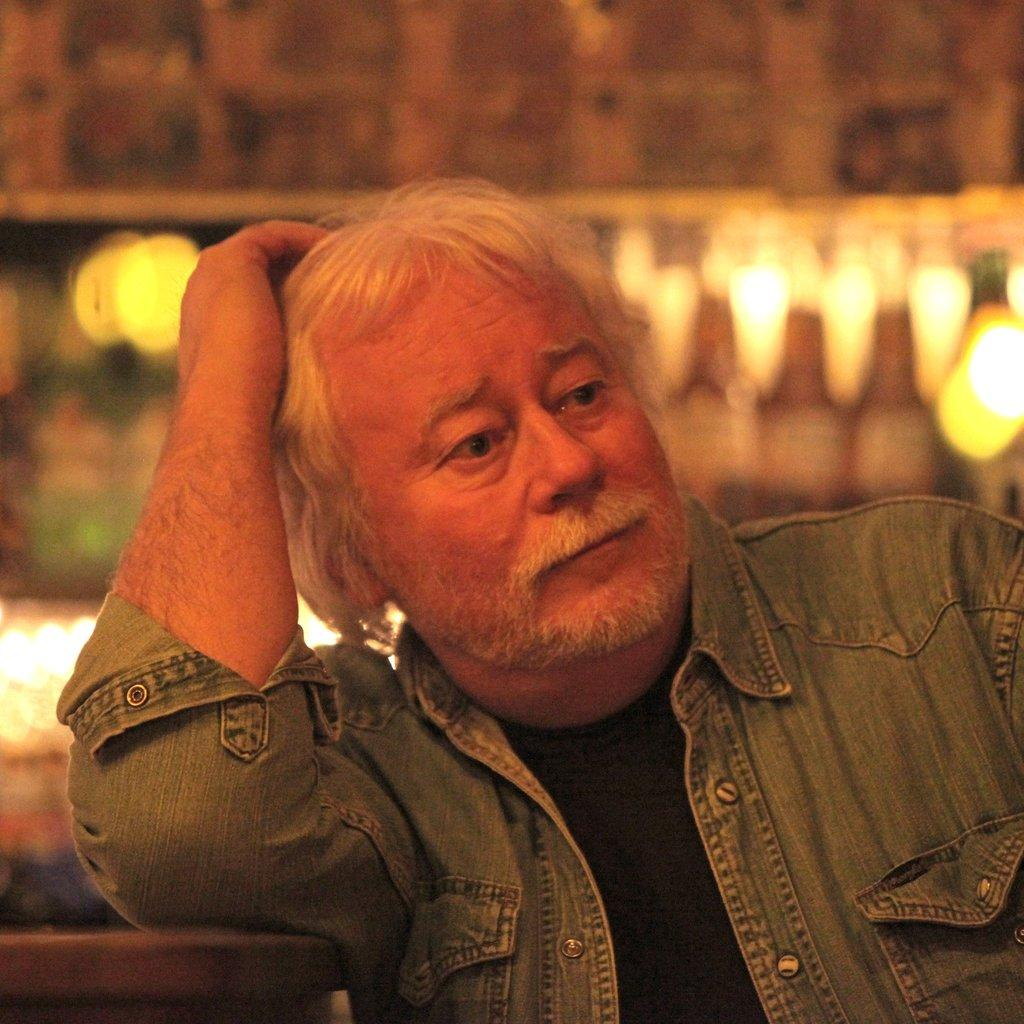Who is present in the image? There is a man in the picture. What is the man wearing? The man is wearing a jacket and a t-shirt. What is the man doing in the image? The man is sitting on a chair. What can be seen in the background of the picture? There are lights and a wall in the background of the picture. What type of poison is the man holding in the image? There is no poison present in the image; the man is simply sitting on a chair wearing a jacket and a t-shirt. 